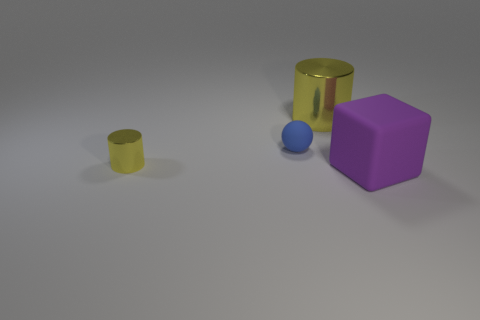There is a object that is the same color as the tiny cylinder; what is its size?
Give a very brief answer. Large. What number of other objects are the same shape as the purple thing?
Your response must be concise. 0. Is the number of tiny blue rubber blocks less than the number of big shiny cylinders?
Your response must be concise. Yes. There is a object that is both right of the tiny sphere and in front of the sphere; what size is it?
Provide a succinct answer. Large. What is the size of the rubber object that is behind the yellow thing that is left of the yellow metallic cylinder to the right of the small rubber object?
Your answer should be very brief. Small. What size is the block?
Make the answer very short. Large. There is a yellow metal cylinder on the right side of the small cylinder to the left of the tiny blue matte sphere; is there a object that is to the left of it?
Provide a short and direct response. Yes. How many large things are yellow metallic things or blue objects?
Offer a very short reply. 1. Is there anything else that has the same color as the sphere?
Give a very brief answer. No. There is a shiny cylinder in front of the blue sphere; is it the same size as the small blue sphere?
Your response must be concise. Yes. 